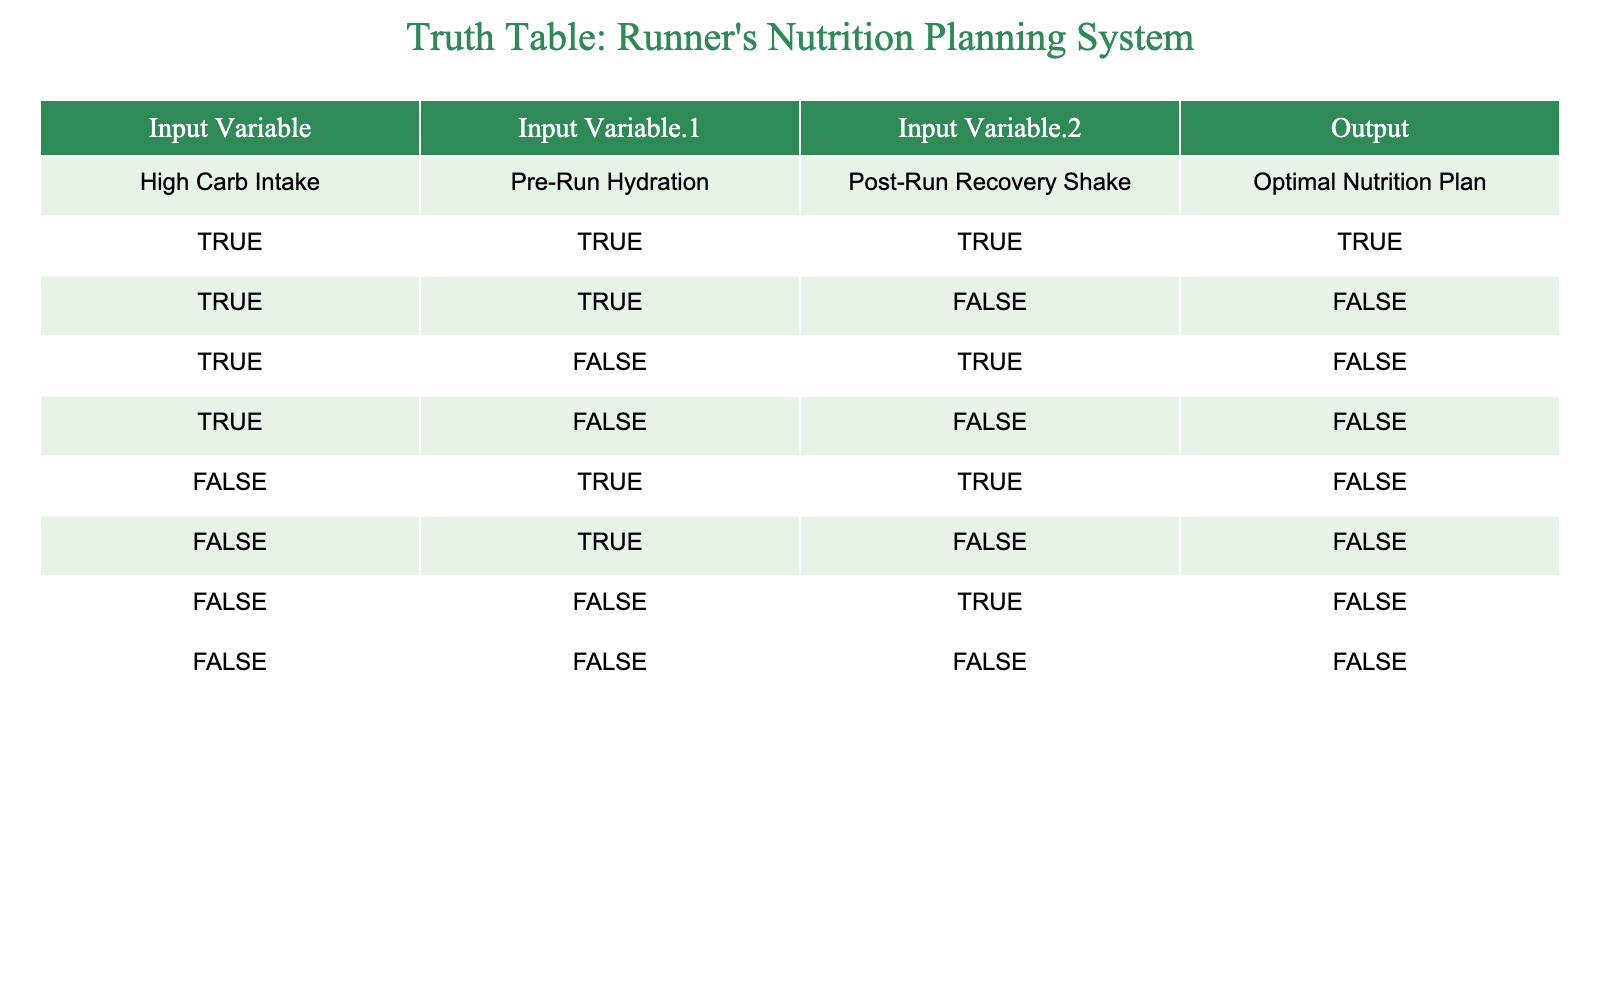What is the output when both High Carb Intake and Pre-Run Hydration are TRUE, and Post-Run Recovery Shake is TRUE? From the first row in the table, when all three input variables are TRUE, the output is also TRUE.
Answer: TRUE How many combinations result in an optimal nutrition plan? The only combination resulting in an optimal nutrition plan (TRUE) appears in the first row. Thus, there is only one combination.
Answer: 1 Is it true that a FALSE value for High Carb Intake leads to an optimal nutrition plan? Looking through all rows where High Carb Intake is FALSE, all corresponding outputs are also FALSE. So, it is not true that a FALSE value leads to an optimal nutrition plan.
Answer: FALSE What is the output if only Post-Run Recovery Shake is TRUE? In the sixth row, where High Carb Intake is FALSE, Pre-Run Hydration is FALSE, and Post-Run Recovery Shake is TRUE, the output is FALSE.
Answer: FALSE Based on the table, can a runner achieve an optimal nutrition plan with high carb intake only? Referring to the second row, with High Carb Intake TRUE, Pre-Run Hydration TRUE, and Post-Run Recovery Shake FALSE, the output is FALSE, indicating that high carb intake alone isn't sufficient. Therefore, a combination of variables is necessary.
Answer: NO If a runner maintains True values for High Carb Intake and Pre-Run Hydration, what is required to achieve an optimal nutrition plan? Looking at the second row, if High Carb Intake is TRUE and Pre-Run Hydration is TRUE, but the Post-Run Recovery Shake is FALSE, the output is FALSE. Therefore, the Post-Run Recovery Shake must be TRUE for an optimal nutrition plan.
Answer: Post-Run Recovery Shake must be TRUE How many total rows in the table yield a FALSE result for the optimal nutrition plan? By counting the rows in the table, we see that there are six rows where the output is FALSE (rows 2 through 8).
Answer: 6 What is the condition for obtaining TRUE in the output when High Carb Intake is FALSE? In rows five and six, where High Carb Intake is FALSE, all outputs are FALSE, which indicates that having TRUE values for the other inputs does not yield an optimal nutrition plan.
Answer: None In how many cases does Post-Run Recovery Shake being TRUE relate to an optimal nutrition plan? Post-Run Recovery Shake is TRUE in rows one and three. However, only in the first row does it lead to an optimal nutrition plan, meaning it does not guarantee the output being TRUE in all cases.
Answer: 1 